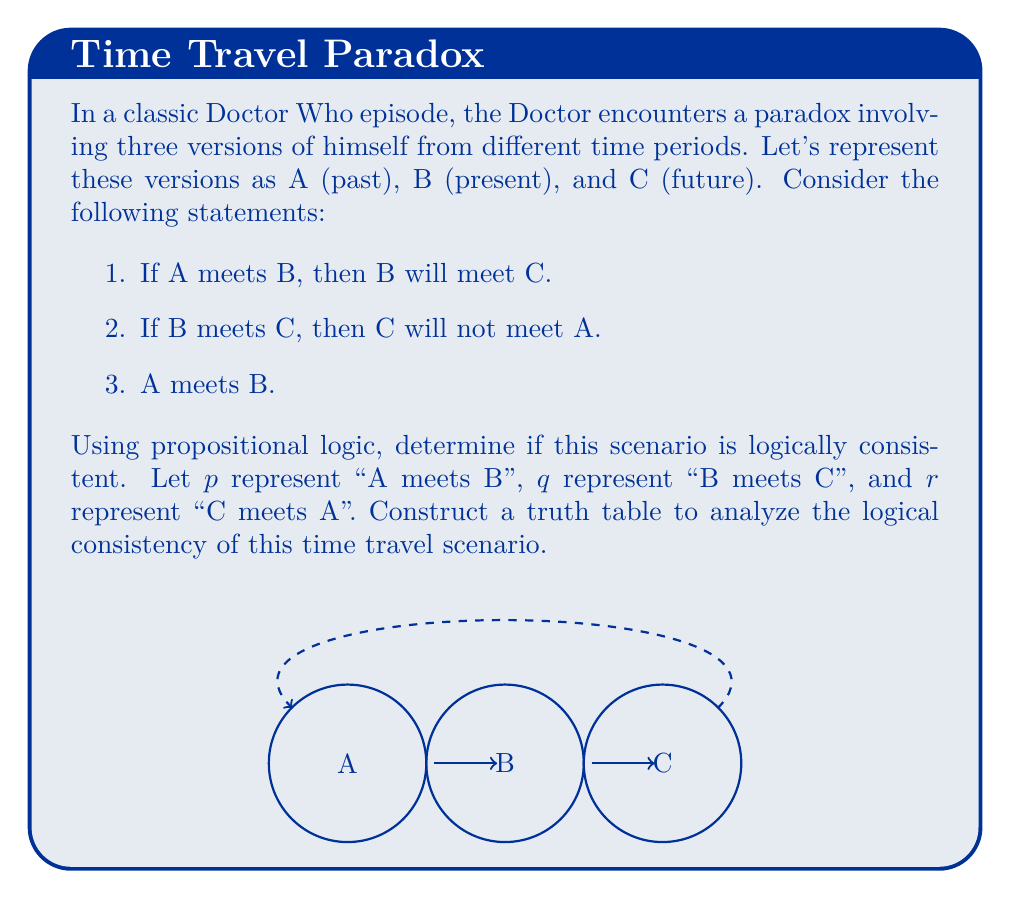Could you help me with this problem? Let's approach this step-by-step:

1. First, we need to translate the given statements into logical propositions:
   - Statement 1: $p \rightarrow q$
   - Statement 2: $q \rightarrow \neg r$
   - Statement 3: $p$

2. We want to check if all these statements can be true simultaneously. To do this, we'll construct a truth table for the compound proposition:

   $$(p \rightarrow q) \wedge (q \rightarrow \neg r) \wedge p$$

3. Let's create the truth table:

   $$\begin{array}{|c|c|c|c|c|c|c|}
   \hline
   p & q & r & p \rightarrow q & q \rightarrow \neg r & (p \rightarrow q) \wedge (q \rightarrow \neg r) & ((p \rightarrow q) \wedge (q \rightarrow \neg r)) \wedge p \\
   \hline
   T & T & T & T & F & F & F \\
   T & T & F & T & T & T & T \\
   T & F & T & F & T & F & F \\
   T & F & F & F & T & F & F \\
   F & T & T & T & F & F & F \\
   F & T & F & T & T & T & F \\
   F & F & T & T & T & T & F \\
   F & F & F & T & T & T & F \\
   \hline
   \end{array}$$

4. From the truth table, we can see that there is one row where all statements are true simultaneously (the second row, where $p$ is true, $q$ is true, and $r$ is false).

5. This means that the scenario is logically consistent. It's possible for all the statements to be true at the same time, which occurs when:
   - A meets B (p is true)
   - B meets C (q is true)
   - C does not meet A (r is false)

6. In the context of the Doctor Who scenario, this means it's logically possible for the past Doctor (A) to meet the present Doctor (B), the present Doctor (B) to meet the future Doctor (C), and for the future Doctor (C) to not meet the past Doctor (A), all without creating a paradox.
Answer: Logically consistent 